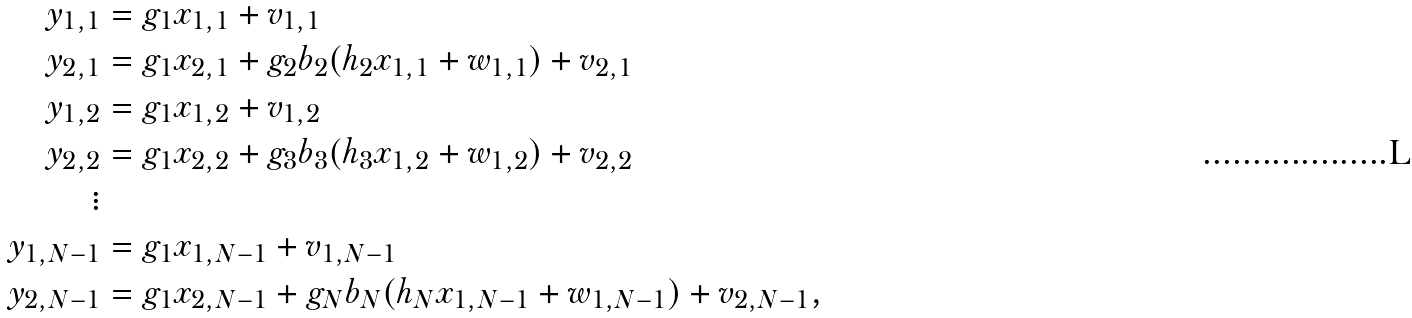Convert formula to latex. <formula><loc_0><loc_0><loc_500><loc_500>y _ { 1 , 1 } & = g _ { 1 } x _ { 1 , 1 } + v _ { 1 , 1 } \\ y _ { 2 , 1 } & = g _ { 1 } x _ { 2 , 1 } + g _ { 2 } b _ { 2 } ( h _ { 2 } x _ { 1 , 1 } + w _ { 1 , 1 } ) + v _ { 2 , 1 } \\ y _ { 1 , 2 } & = g _ { 1 } x _ { 1 , 2 } + v _ { 1 , 2 } \\ y _ { 2 , 2 } & = g _ { 1 } x _ { 2 , 2 } + g _ { 3 } b _ { 3 } ( h _ { 3 } x _ { 1 , 2 } + w _ { 1 , 2 } ) + v _ { 2 , 2 } \\ \vdots & \\ y _ { 1 , N - 1 } & = g _ { 1 } x _ { 1 , N - 1 } + v _ { 1 , N - 1 } \\ y _ { 2 , N - 1 } & = g _ { 1 } x _ { 2 , N - 1 } + g _ { N } b _ { N } ( h _ { N } x _ { 1 , N - 1 } + w _ { 1 , N - 1 } ) + v _ { 2 , N - 1 } ,</formula> 